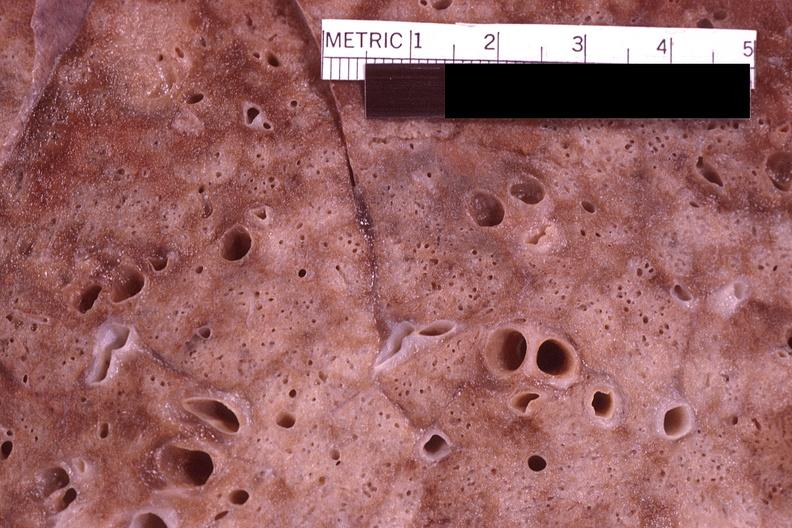what does this image show?
Answer the question using a single word or phrase. Lung 